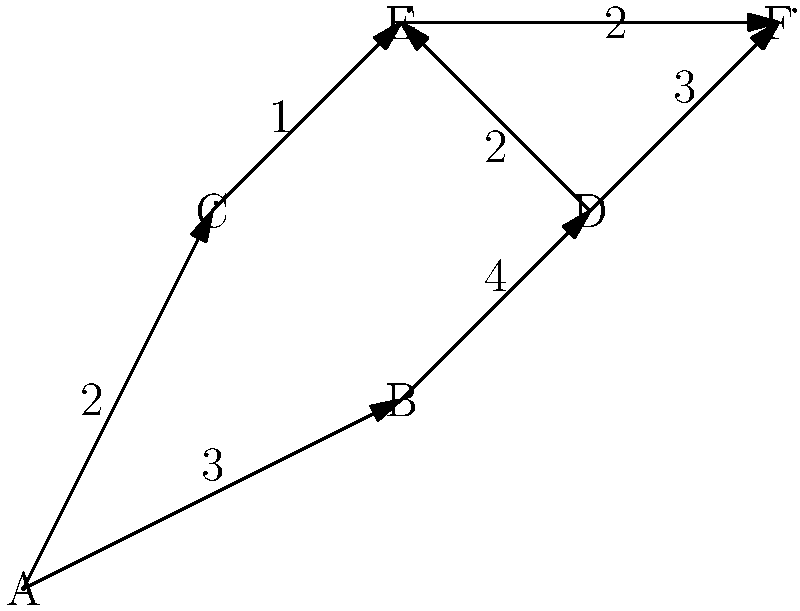You're designing a new skate park and want to determine the optimal path for a continuous flow of skaters. The park is represented as a directed graph where nodes are key features (ramps, rails, etc.) and edges are possible transitions between them. Each edge has a weight representing the difficulty level (1 being easiest, 5 being hardest). What is the path from node A to node F that minimizes the maximum difficulty level encountered? To find the path from A to F that minimizes the maximum difficulty level, we'll use a modified version of Dijkstra's algorithm, focusing on minimizing the maximum edge weight rather than the sum of weights. Here's the step-by-step process:

1. Initialize all nodes with an infinite maximum difficulty, except A which starts at 0.
2. Start from node A and explore its neighbors:
   - A to B: max difficulty = 3
   - A to C: max difficulty = 2
3. Move to C (lowest max difficulty):
   - C to E: max difficulty = max(2, 1) = 2
4. Move to E:
   - E to F: max difficulty = max(2, 2) = 2
5. Move to B:
   - B to D: max difficulty = max(3, 4) = 4
6. Move to D:
   - D to E: max difficulty = max(4, 2) = 4
   - D to F: max difficulty = max(4, 3) = 4

The path A -> C -> E -> F has been found with a maximum difficulty of 2, which is lower than any other path to F.

Therefore, the optimal path minimizing the maximum difficulty is A -> C -> E -> F.
Answer: A -> C -> E -> F 